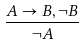Convert formula to latex. <formula><loc_0><loc_0><loc_500><loc_500>\frac { A \rightarrow B , \neg B } { \neg A }</formula> 